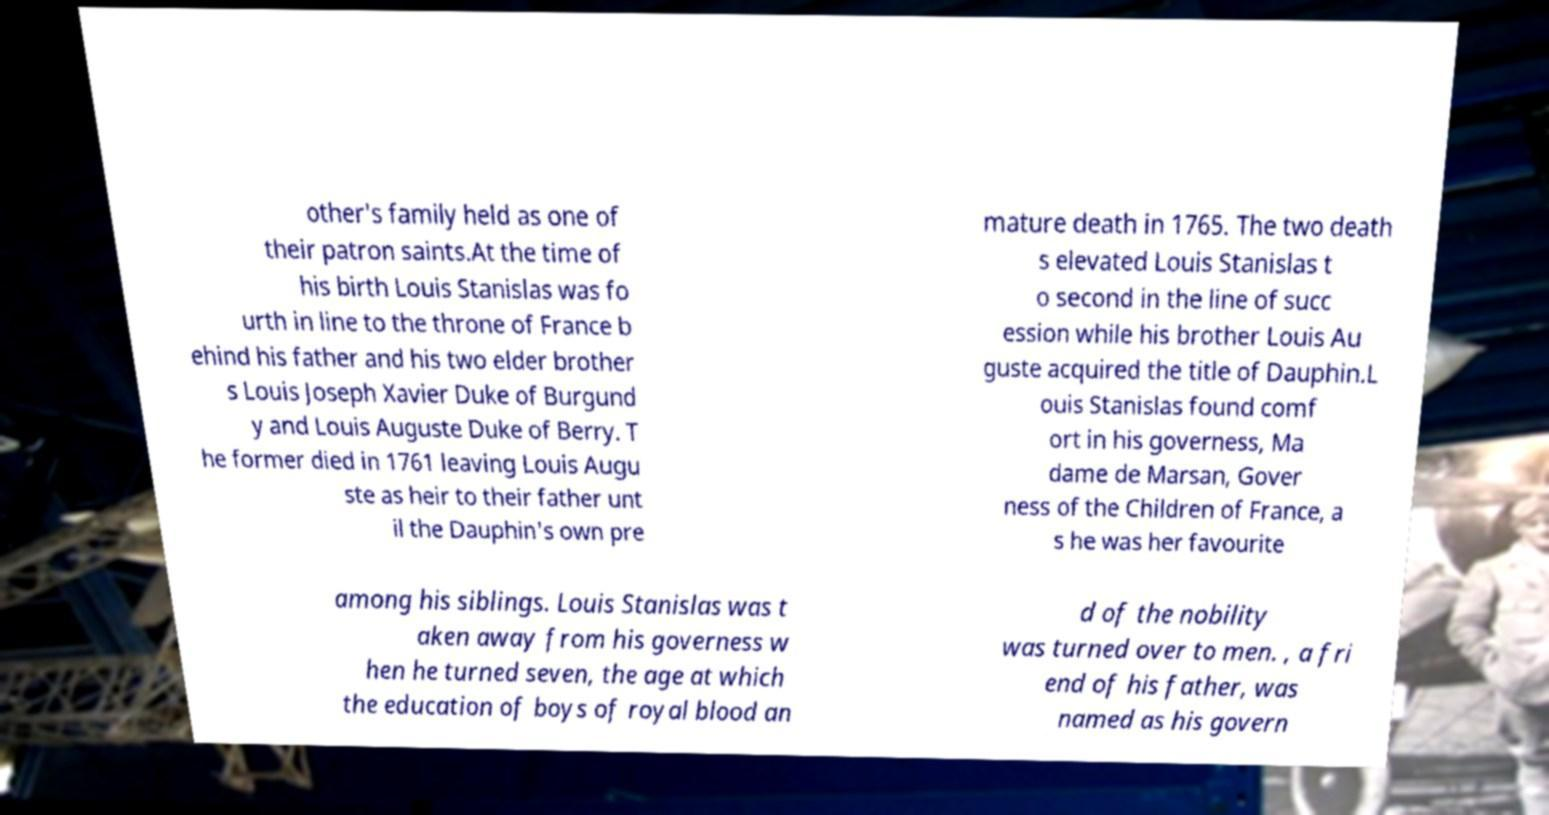Could you extract and type out the text from this image? other's family held as one of their patron saints.At the time of his birth Louis Stanislas was fo urth in line to the throne of France b ehind his father and his two elder brother s Louis Joseph Xavier Duke of Burgund y and Louis Auguste Duke of Berry. T he former died in 1761 leaving Louis Augu ste as heir to their father unt il the Dauphin's own pre mature death in 1765. The two death s elevated Louis Stanislas t o second in the line of succ ession while his brother Louis Au guste acquired the title of Dauphin.L ouis Stanislas found comf ort in his governess, Ma dame de Marsan, Gover ness of the Children of France, a s he was her favourite among his siblings. Louis Stanislas was t aken away from his governess w hen he turned seven, the age at which the education of boys of royal blood an d of the nobility was turned over to men. , a fri end of his father, was named as his govern 